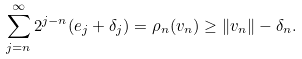Convert formula to latex. <formula><loc_0><loc_0><loc_500><loc_500>\sum _ { j = n } ^ { \infty } 2 ^ { j - n } ( e _ { j } + \delta _ { j } ) = \rho _ { n } ( v _ { n } ) \geq \| v _ { n } \| - \delta _ { n } .</formula> 